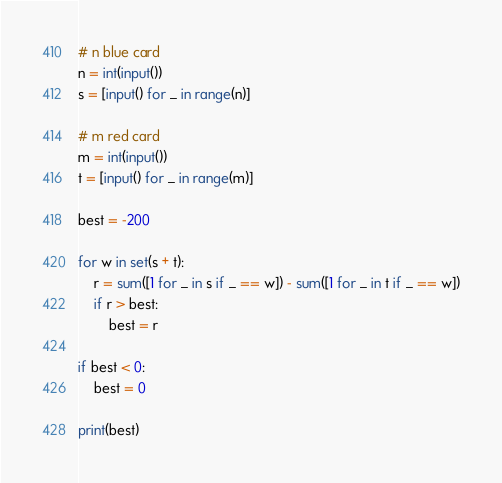Convert code to text. <code><loc_0><loc_0><loc_500><loc_500><_Python_># n blue card
n = int(input())
s = [input() for _ in range(n)]

# m red card
m = int(input())
t = [input() for _ in range(m)]

best = -200

for w in set(s + t):
    r = sum([1 for _ in s if _ == w]) - sum([1 for _ in t if _ == w])
    if r > best:
        best = r

if best < 0:
    best = 0
    
print(best)
</code> 